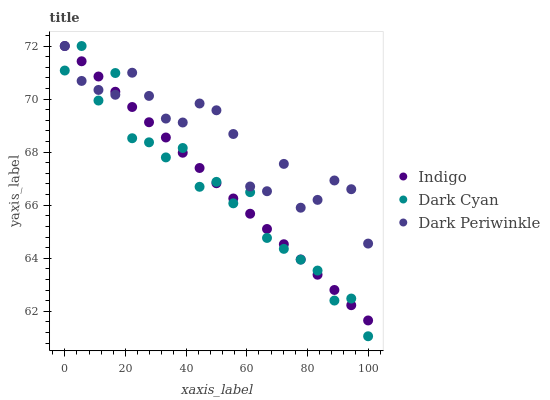Does Dark Cyan have the minimum area under the curve?
Answer yes or no. Yes. Does Dark Periwinkle have the maximum area under the curve?
Answer yes or no. Yes. Does Indigo have the minimum area under the curve?
Answer yes or no. No. Does Indigo have the maximum area under the curve?
Answer yes or no. No. Is Indigo the smoothest?
Answer yes or no. Yes. Is Dark Cyan the roughest?
Answer yes or no. Yes. Is Dark Periwinkle the smoothest?
Answer yes or no. No. Is Dark Periwinkle the roughest?
Answer yes or no. No. Does Dark Cyan have the lowest value?
Answer yes or no. Yes. Does Indigo have the lowest value?
Answer yes or no. No. Does Dark Periwinkle have the highest value?
Answer yes or no. Yes. Does Dark Periwinkle intersect Dark Cyan?
Answer yes or no. Yes. Is Dark Periwinkle less than Dark Cyan?
Answer yes or no. No. Is Dark Periwinkle greater than Dark Cyan?
Answer yes or no. No. 